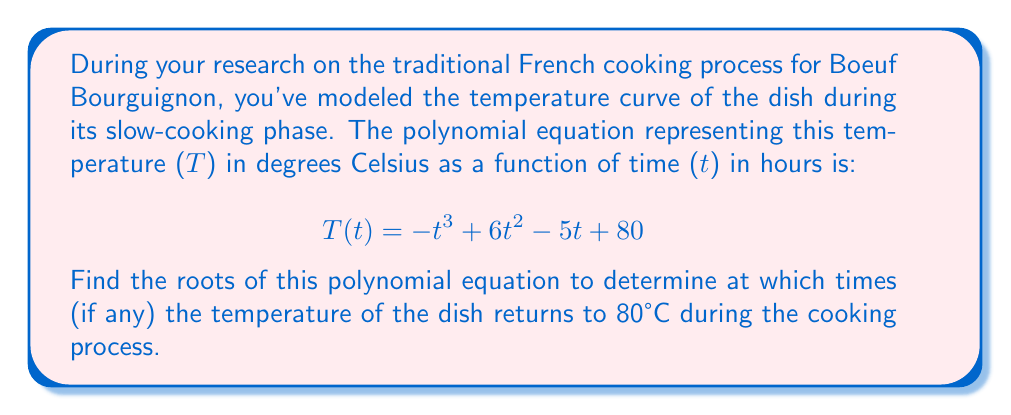Show me your answer to this math problem. To find the roots of this polynomial equation, we need to solve:

$$-t^3 + 6t^2 - 5t + 80 = 80$$

Simplifying:

$$-t^3 + 6t^2 - 5t = 0$$

Factor out the greatest common factor:

$$-t(t^2 - 6t + 5) = 0$$

Using the zero product property, we can split this into two equations:

1) $-t = 0$, which gives us $t = 0$
2) $t^2 - 6t + 5 = 0$

For the second equation, we can use the quadratic formula: $t = \frac{-b \pm \sqrt{b^2 - 4ac}}{2a}$

Where $a = 1$, $b = -6$, and $c = 5$

$$t = \frac{6 \pm \sqrt{36 - 20}}{2} = \frac{6 \pm \sqrt{16}}{2} = \frac{6 \pm 4}{2}$$

This gives us two more solutions:

$t = \frac{6 + 4}{2} = 5$ and $t = \frac{6 - 4}{2} = 1$

Therefore, the roots of the polynomial are 0, 1, and 5.

However, considering the context of the problem, t = 0 is not a meaningful solution as it represents the start of the cooking process when the temperature is already at 80°C. The relevant solutions are t = 1 and t = 5.
Answer: The temperature of the Boeuf Bourguignon returns to 80°C at t = 1 hour and t = 5 hours during the cooking process. 